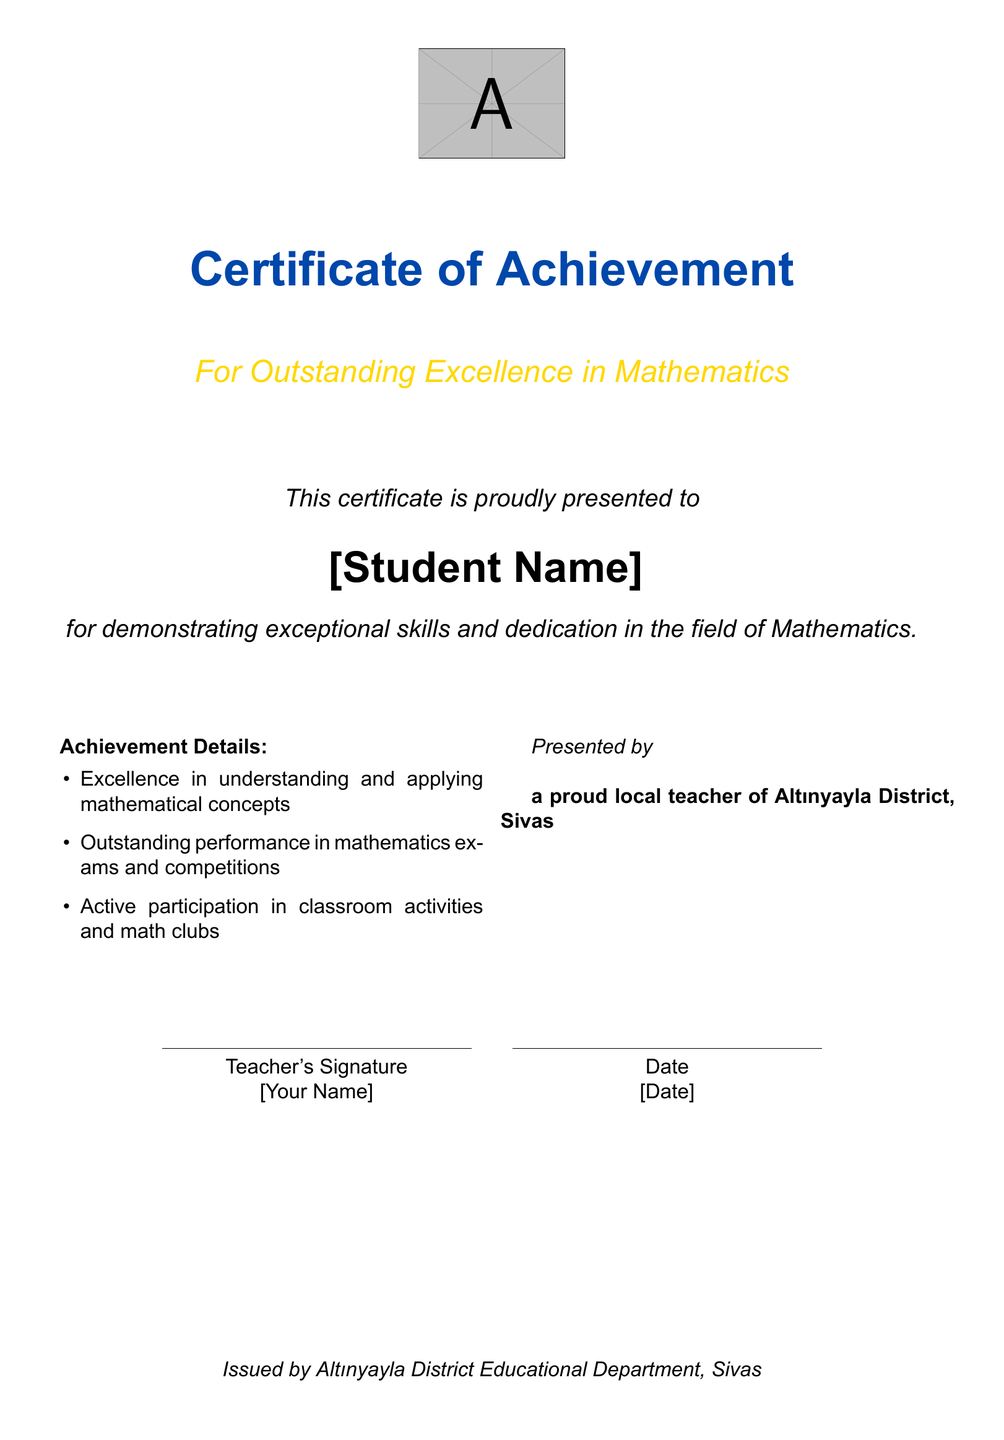what is the title of the certificate? The title of the certificate is prominently displayed near the top of the document.
Answer: Certificate of Achievement who is the certificate presented to? The recipient's name is indicated in a prominent format in the document.
Answer: [Student Name] what is the subtitle of the certificate? The subtitle provides specific context regarding the achievement recognized by the certificate.
Answer: For Outstanding Excellence in Mathematics who issues the certificate? The issuing entity is mentioned at the bottom of the document.
Answer: Altınyayla District Educational Department, Sivas what are the achievement details listed? The details regarding the achievement are found in the designated section of the certificate.
Answer: Understanding, performance, participation what is the color of the certificate title? The color used for the title is specified within the document.
Answer: certblue what role does the presenter have? The presenter’s position is indicated in the document.
Answer: Teacher how many columns are there in the details section? The layout of the document specifies the number of columns utilized.
Answer: 2 